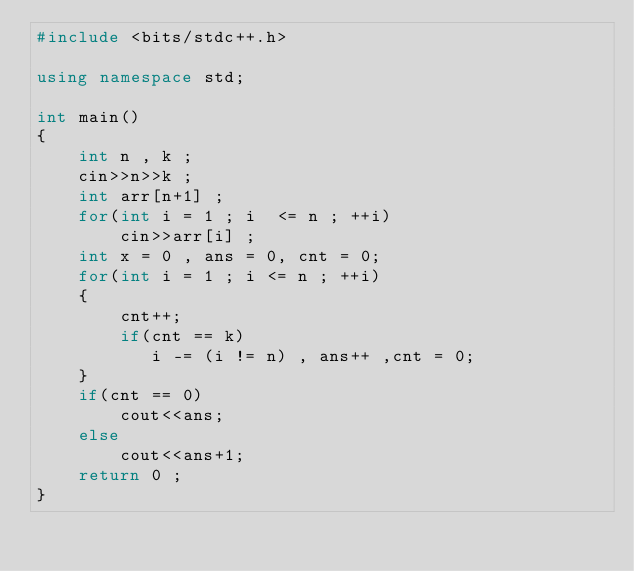<code> <loc_0><loc_0><loc_500><loc_500><_C++_>#include <bits/stdc++.h>

using namespace std;

int main()
{
    int n , k ;
    cin>>n>>k ;
    int arr[n+1] ;
    for(int i = 1 ; i  <= n ; ++i)
        cin>>arr[i] ;
    int x = 0 , ans = 0, cnt = 0;
    for(int i = 1 ; i <= n ; ++i)
    {
        cnt++;
        if(cnt == k)
           i -= (i != n) , ans++ ,cnt = 0;
    }
    if(cnt == 0)
        cout<<ans;
    else
        cout<<ans+1;
    return 0 ;
}
</code> 